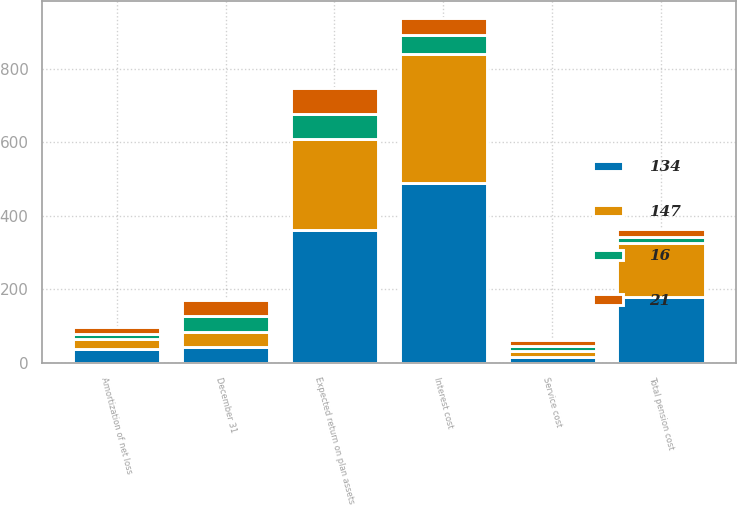Convert chart. <chart><loc_0><loc_0><loc_500><loc_500><stacked_bar_chart><ecel><fcel>December 31<fcel>Service cost<fcel>Interest cost<fcel>Expected return on plan assets<fcel>Amortization of net loss<fcel>Total pension cost<nl><fcel>21<fcel>42.5<fcel>16<fcel>48<fcel>70<fcel>20<fcel>21<nl><fcel>147<fcel>42.5<fcel>15<fcel>351<fcel>247<fcel>28<fcel>147<nl><fcel>16<fcel>42.5<fcel>14<fcel>50<fcel>67<fcel>13<fcel>16<nl><fcel>134<fcel>42.5<fcel>16<fcel>489<fcel>362<fcel>37<fcel>180<nl></chart> 